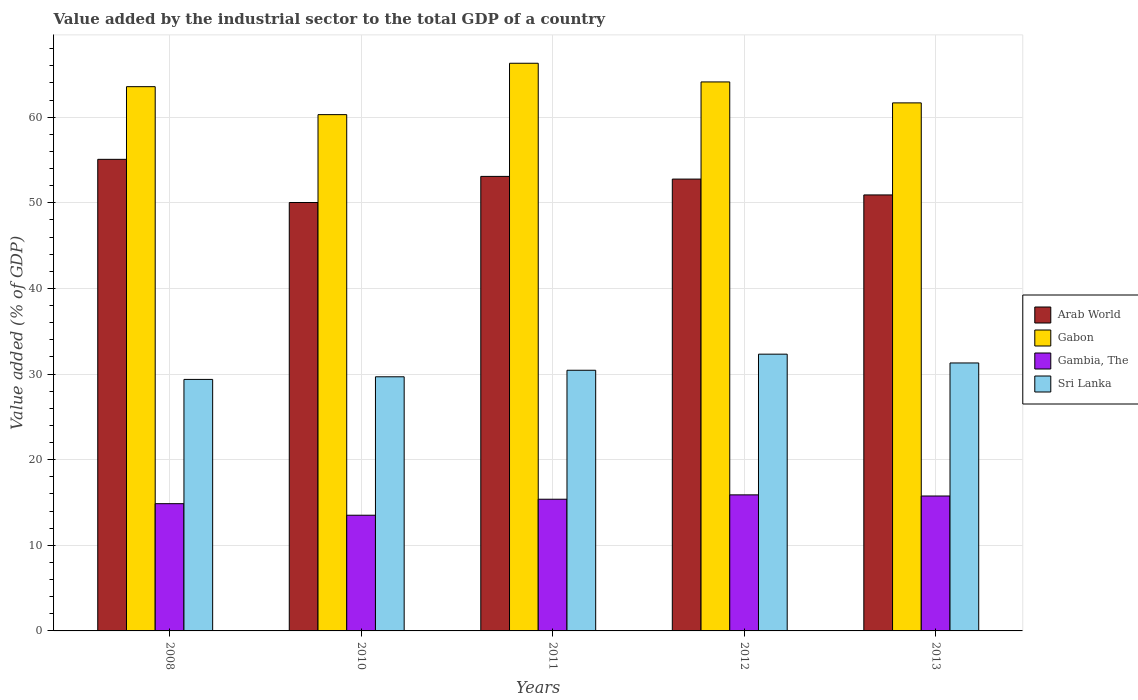How many bars are there on the 4th tick from the left?
Provide a short and direct response. 4. How many bars are there on the 4th tick from the right?
Ensure brevity in your answer.  4. What is the label of the 2nd group of bars from the left?
Your response must be concise. 2010. What is the value added by the industrial sector to the total GDP in Sri Lanka in 2011?
Provide a succinct answer. 30.44. Across all years, what is the maximum value added by the industrial sector to the total GDP in Sri Lanka?
Your answer should be compact. 32.32. Across all years, what is the minimum value added by the industrial sector to the total GDP in Gabon?
Offer a very short reply. 60.29. In which year was the value added by the industrial sector to the total GDP in Gabon minimum?
Provide a short and direct response. 2010. What is the total value added by the industrial sector to the total GDP in Arab World in the graph?
Ensure brevity in your answer.  261.87. What is the difference between the value added by the industrial sector to the total GDP in Gambia, The in 2011 and that in 2012?
Your answer should be very brief. -0.51. What is the difference between the value added by the industrial sector to the total GDP in Arab World in 2008 and the value added by the industrial sector to the total GDP in Gambia, The in 2010?
Your answer should be compact. 41.56. What is the average value added by the industrial sector to the total GDP in Gabon per year?
Provide a succinct answer. 63.18. In the year 2013, what is the difference between the value added by the industrial sector to the total GDP in Arab World and value added by the industrial sector to the total GDP in Gabon?
Your answer should be very brief. -10.75. What is the ratio of the value added by the industrial sector to the total GDP in Arab World in 2008 to that in 2010?
Your response must be concise. 1.1. Is the difference between the value added by the industrial sector to the total GDP in Arab World in 2011 and 2013 greater than the difference between the value added by the industrial sector to the total GDP in Gabon in 2011 and 2013?
Your answer should be very brief. No. What is the difference between the highest and the second highest value added by the industrial sector to the total GDP in Gabon?
Provide a short and direct response. 2.18. What is the difference between the highest and the lowest value added by the industrial sector to the total GDP in Sri Lanka?
Make the answer very short. 2.95. Is the sum of the value added by the industrial sector to the total GDP in Arab World in 2010 and 2013 greater than the maximum value added by the industrial sector to the total GDP in Gabon across all years?
Ensure brevity in your answer.  Yes. What does the 1st bar from the left in 2010 represents?
Your answer should be compact. Arab World. What does the 2nd bar from the right in 2008 represents?
Make the answer very short. Gambia, The. Are all the bars in the graph horizontal?
Your answer should be very brief. No. What is the difference between two consecutive major ticks on the Y-axis?
Provide a succinct answer. 10. Are the values on the major ticks of Y-axis written in scientific E-notation?
Provide a short and direct response. No. Does the graph contain grids?
Your answer should be very brief. Yes. How many legend labels are there?
Give a very brief answer. 4. How are the legend labels stacked?
Give a very brief answer. Vertical. What is the title of the graph?
Provide a succinct answer. Value added by the industrial sector to the total GDP of a country. What is the label or title of the X-axis?
Give a very brief answer. Years. What is the label or title of the Y-axis?
Give a very brief answer. Value added (% of GDP). What is the Value added (% of GDP) of Arab World in 2008?
Offer a very short reply. 55.07. What is the Value added (% of GDP) of Gabon in 2008?
Your answer should be very brief. 63.56. What is the Value added (% of GDP) in Gambia, The in 2008?
Your answer should be compact. 14.86. What is the Value added (% of GDP) in Sri Lanka in 2008?
Offer a terse response. 29.37. What is the Value added (% of GDP) in Arab World in 2010?
Offer a very short reply. 50.03. What is the Value added (% of GDP) in Gabon in 2010?
Provide a succinct answer. 60.29. What is the Value added (% of GDP) in Gambia, The in 2010?
Your answer should be very brief. 13.51. What is the Value added (% of GDP) of Sri Lanka in 2010?
Your answer should be very brief. 29.68. What is the Value added (% of GDP) in Arab World in 2011?
Your response must be concise. 53.08. What is the Value added (% of GDP) of Gabon in 2011?
Your response must be concise. 66.29. What is the Value added (% of GDP) in Gambia, The in 2011?
Give a very brief answer. 15.38. What is the Value added (% of GDP) of Sri Lanka in 2011?
Your answer should be very brief. 30.44. What is the Value added (% of GDP) in Arab World in 2012?
Your answer should be compact. 52.77. What is the Value added (% of GDP) in Gabon in 2012?
Ensure brevity in your answer.  64.11. What is the Value added (% of GDP) in Gambia, The in 2012?
Offer a terse response. 15.89. What is the Value added (% of GDP) in Sri Lanka in 2012?
Your answer should be very brief. 32.32. What is the Value added (% of GDP) in Arab World in 2013?
Ensure brevity in your answer.  50.92. What is the Value added (% of GDP) in Gabon in 2013?
Keep it short and to the point. 61.67. What is the Value added (% of GDP) in Gambia, The in 2013?
Provide a succinct answer. 15.75. What is the Value added (% of GDP) in Sri Lanka in 2013?
Your response must be concise. 31.29. Across all years, what is the maximum Value added (% of GDP) of Arab World?
Offer a terse response. 55.07. Across all years, what is the maximum Value added (% of GDP) in Gabon?
Ensure brevity in your answer.  66.29. Across all years, what is the maximum Value added (% of GDP) in Gambia, The?
Your response must be concise. 15.89. Across all years, what is the maximum Value added (% of GDP) of Sri Lanka?
Offer a very short reply. 32.32. Across all years, what is the minimum Value added (% of GDP) of Arab World?
Provide a succinct answer. 50.03. Across all years, what is the minimum Value added (% of GDP) of Gabon?
Give a very brief answer. 60.29. Across all years, what is the minimum Value added (% of GDP) in Gambia, The?
Ensure brevity in your answer.  13.51. Across all years, what is the minimum Value added (% of GDP) of Sri Lanka?
Make the answer very short. 29.37. What is the total Value added (% of GDP) in Arab World in the graph?
Make the answer very short. 261.87. What is the total Value added (% of GDP) of Gabon in the graph?
Your response must be concise. 315.92. What is the total Value added (% of GDP) of Gambia, The in the graph?
Your response must be concise. 75.39. What is the total Value added (% of GDP) in Sri Lanka in the graph?
Make the answer very short. 153.1. What is the difference between the Value added (% of GDP) of Arab World in 2008 and that in 2010?
Your answer should be very brief. 5.04. What is the difference between the Value added (% of GDP) of Gabon in 2008 and that in 2010?
Your response must be concise. 3.27. What is the difference between the Value added (% of GDP) in Gambia, The in 2008 and that in 2010?
Keep it short and to the point. 1.35. What is the difference between the Value added (% of GDP) of Sri Lanka in 2008 and that in 2010?
Your response must be concise. -0.31. What is the difference between the Value added (% of GDP) of Arab World in 2008 and that in 2011?
Your response must be concise. 1.99. What is the difference between the Value added (% of GDP) of Gabon in 2008 and that in 2011?
Your answer should be very brief. -2.73. What is the difference between the Value added (% of GDP) of Gambia, The in 2008 and that in 2011?
Your answer should be compact. -0.52. What is the difference between the Value added (% of GDP) of Sri Lanka in 2008 and that in 2011?
Your response must be concise. -1.07. What is the difference between the Value added (% of GDP) of Arab World in 2008 and that in 2012?
Provide a short and direct response. 2.31. What is the difference between the Value added (% of GDP) in Gabon in 2008 and that in 2012?
Provide a succinct answer. -0.55. What is the difference between the Value added (% of GDP) of Gambia, The in 2008 and that in 2012?
Your answer should be compact. -1.03. What is the difference between the Value added (% of GDP) in Sri Lanka in 2008 and that in 2012?
Make the answer very short. -2.95. What is the difference between the Value added (% of GDP) of Arab World in 2008 and that in 2013?
Offer a very short reply. 4.16. What is the difference between the Value added (% of GDP) of Gabon in 2008 and that in 2013?
Your answer should be compact. 1.89. What is the difference between the Value added (% of GDP) of Gambia, The in 2008 and that in 2013?
Make the answer very short. -0.89. What is the difference between the Value added (% of GDP) of Sri Lanka in 2008 and that in 2013?
Provide a short and direct response. -1.92. What is the difference between the Value added (% of GDP) in Arab World in 2010 and that in 2011?
Make the answer very short. -3.05. What is the difference between the Value added (% of GDP) of Gabon in 2010 and that in 2011?
Provide a succinct answer. -6. What is the difference between the Value added (% of GDP) of Gambia, The in 2010 and that in 2011?
Provide a succinct answer. -1.87. What is the difference between the Value added (% of GDP) of Sri Lanka in 2010 and that in 2011?
Your answer should be compact. -0.76. What is the difference between the Value added (% of GDP) of Arab World in 2010 and that in 2012?
Provide a succinct answer. -2.73. What is the difference between the Value added (% of GDP) in Gabon in 2010 and that in 2012?
Your response must be concise. -3.82. What is the difference between the Value added (% of GDP) of Gambia, The in 2010 and that in 2012?
Give a very brief answer. -2.38. What is the difference between the Value added (% of GDP) of Sri Lanka in 2010 and that in 2012?
Your answer should be compact. -2.64. What is the difference between the Value added (% of GDP) of Arab World in 2010 and that in 2013?
Give a very brief answer. -0.89. What is the difference between the Value added (% of GDP) in Gabon in 2010 and that in 2013?
Your answer should be very brief. -1.37. What is the difference between the Value added (% of GDP) of Gambia, The in 2010 and that in 2013?
Your response must be concise. -2.24. What is the difference between the Value added (% of GDP) of Sri Lanka in 2010 and that in 2013?
Your answer should be compact. -1.61. What is the difference between the Value added (% of GDP) of Arab World in 2011 and that in 2012?
Give a very brief answer. 0.31. What is the difference between the Value added (% of GDP) of Gabon in 2011 and that in 2012?
Offer a very short reply. 2.18. What is the difference between the Value added (% of GDP) in Gambia, The in 2011 and that in 2012?
Your answer should be compact. -0.51. What is the difference between the Value added (% of GDP) of Sri Lanka in 2011 and that in 2012?
Your answer should be compact. -1.88. What is the difference between the Value added (% of GDP) of Arab World in 2011 and that in 2013?
Provide a succinct answer. 2.16. What is the difference between the Value added (% of GDP) of Gabon in 2011 and that in 2013?
Make the answer very short. 4.63. What is the difference between the Value added (% of GDP) of Gambia, The in 2011 and that in 2013?
Your response must be concise. -0.37. What is the difference between the Value added (% of GDP) in Sri Lanka in 2011 and that in 2013?
Make the answer very short. -0.85. What is the difference between the Value added (% of GDP) in Arab World in 2012 and that in 2013?
Your response must be concise. 1.85. What is the difference between the Value added (% of GDP) of Gabon in 2012 and that in 2013?
Offer a terse response. 2.45. What is the difference between the Value added (% of GDP) in Gambia, The in 2012 and that in 2013?
Offer a terse response. 0.13. What is the difference between the Value added (% of GDP) of Sri Lanka in 2012 and that in 2013?
Provide a succinct answer. 1.03. What is the difference between the Value added (% of GDP) of Arab World in 2008 and the Value added (% of GDP) of Gabon in 2010?
Ensure brevity in your answer.  -5.22. What is the difference between the Value added (% of GDP) in Arab World in 2008 and the Value added (% of GDP) in Gambia, The in 2010?
Offer a very short reply. 41.56. What is the difference between the Value added (% of GDP) of Arab World in 2008 and the Value added (% of GDP) of Sri Lanka in 2010?
Make the answer very short. 25.4. What is the difference between the Value added (% of GDP) of Gabon in 2008 and the Value added (% of GDP) of Gambia, The in 2010?
Provide a short and direct response. 50.05. What is the difference between the Value added (% of GDP) of Gabon in 2008 and the Value added (% of GDP) of Sri Lanka in 2010?
Provide a succinct answer. 33.88. What is the difference between the Value added (% of GDP) of Gambia, The in 2008 and the Value added (% of GDP) of Sri Lanka in 2010?
Provide a succinct answer. -14.82. What is the difference between the Value added (% of GDP) of Arab World in 2008 and the Value added (% of GDP) of Gabon in 2011?
Provide a succinct answer. -11.22. What is the difference between the Value added (% of GDP) in Arab World in 2008 and the Value added (% of GDP) in Gambia, The in 2011?
Offer a terse response. 39.69. What is the difference between the Value added (% of GDP) of Arab World in 2008 and the Value added (% of GDP) of Sri Lanka in 2011?
Provide a succinct answer. 24.63. What is the difference between the Value added (% of GDP) in Gabon in 2008 and the Value added (% of GDP) in Gambia, The in 2011?
Offer a very short reply. 48.18. What is the difference between the Value added (% of GDP) of Gabon in 2008 and the Value added (% of GDP) of Sri Lanka in 2011?
Provide a succinct answer. 33.12. What is the difference between the Value added (% of GDP) of Gambia, The in 2008 and the Value added (% of GDP) of Sri Lanka in 2011?
Provide a short and direct response. -15.58. What is the difference between the Value added (% of GDP) in Arab World in 2008 and the Value added (% of GDP) in Gabon in 2012?
Your response must be concise. -9.04. What is the difference between the Value added (% of GDP) of Arab World in 2008 and the Value added (% of GDP) of Gambia, The in 2012?
Provide a succinct answer. 39.18. What is the difference between the Value added (% of GDP) in Arab World in 2008 and the Value added (% of GDP) in Sri Lanka in 2012?
Keep it short and to the point. 22.75. What is the difference between the Value added (% of GDP) in Gabon in 2008 and the Value added (% of GDP) in Gambia, The in 2012?
Make the answer very short. 47.67. What is the difference between the Value added (% of GDP) of Gabon in 2008 and the Value added (% of GDP) of Sri Lanka in 2012?
Offer a very short reply. 31.24. What is the difference between the Value added (% of GDP) in Gambia, The in 2008 and the Value added (% of GDP) in Sri Lanka in 2012?
Provide a short and direct response. -17.46. What is the difference between the Value added (% of GDP) in Arab World in 2008 and the Value added (% of GDP) in Gabon in 2013?
Your response must be concise. -6.59. What is the difference between the Value added (% of GDP) in Arab World in 2008 and the Value added (% of GDP) in Gambia, The in 2013?
Offer a very short reply. 39.32. What is the difference between the Value added (% of GDP) of Arab World in 2008 and the Value added (% of GDP) of Sri Lanka in 2013?
Give a very brief answer. 23.78. What is the difference between the Value added (% of GDP) of Gabon in 2008 and the Value added (% of GDP) of Gambia, The in 2013?
Ensure brevity in your answer.  47.8. What is the difference between the Value added (% of GDP) of Gabon in 2008 and the Value added (% of GDP) of Sri Lanka in 2013?
Your response must be concise. 32.27. What is the difference between the Value added (% of GDP) of Gambia, The in 2008 and the Value added (% of GDP) of Sri Lanka in 2013?
Give a very brief answer. -16.43. What is the difference between the Value added (% of GDP) in Arab World in 2010 and the Value added (% of GDP) in Gabon in 2011?
Keep it short and to the point. -16.26. What is the difference between the Value added (% of GDP) of Arab World in 2010 and the Value added (% of GDP) of Gambia, The in 2011?
Give a very brief answer. 34.65. What is the difference between the Value added (% of GDP) in Arab World in 2010 and the Value added (% of GDP) in Sri Lanka in 2011?
Your response must be concise. 19.59. What is the difference between the Value added (% of GDP) in Gabon in 2010 and the Value added (% of GDP) in Gambia, The in 2011?
Your answer should be very brief. 44.91. What is the difference between the Value added (% of GDP) of Gabon in 2010 and the Value added (% of GDP) of Sri Lanka in 2011?
Ensure brevity in your answer.  29.85. What is the difference between the Value added (% of GDP) of Gambia, The in 2010 and the Value added (% of GDP) of Sri Lanka in 2011?
Keep it short and to the point. -16.93. What is the difference between the Value added (% of GDP) of Arab World in 2010 and the Value added (% of GDP) of Gabon in 2012?
Make the answer very short. -14.08. What is the difference between the Value added (% of GDP) of Arab World in 2010 and the Value added (% of GDP) of Gambia, The in 2012?
Keep it short and to the point. 34.14. What is the difference between the Value added (% of GDP) in Arab World in 2010 and the Value added (% of GDP) in Sri Lanka in 2012?
Provide a short and direct response. 17.71. What is the difference between the Value added (% of GDP) of Gabon in 2010 and the Value added (% of GDP) of Gambia, The in 2012?
Your response must be concise. 44.4. What is the difference between the Value added (% of GDP) in Gabon in 2010 and the Value added (% of GDP) in Sri Lanka in 2012?
Keep it short and to the point. 27.97. What is the difference between the Value added (% of GDP) in Gambia, The in 2010 and the Value added (% of GDP) in Sri Lanka in 2012?
Make the answer very short. -18.81. What is the difference between the Value added (% of GDP) in Arab World in 2010 and the Value added (% of GDP) in Gabon in 2013?
Your response must be concise. -11.63. What is the difference between the Value added (% of GDP) in Arab World in 2010 and the Value added (% of GDP) in Gambia, The in 2013?
Make the answer very short. 34.28. What is the difference between the Value added (% of GDP) of Arab World in 2010 and the Value added (% of GDP) of Sri Lanka in 2013?
Your response must be concise. 18.74. What is the difference between the Value added (% of GDP) of Gabon in 2010 and the Value added (% of GDP) of Gambia, The in 2013?
Make the answer very short. 44.54. What is the difference between the Value added (% of GDP) in Gabon in 2010 and the Value added (% of GDP) in Sri Lanka in 2013?
Your answer should be compact. 29. What is the difference between the Value added (% of GDP) in Gambia, The in 2010 and the Value added (% of GDP) in Sri Lanka in 2013?
Your answer should be compact. -17.78. What is the difference between the Value added (% of GDP) in Arab World in 2011 and the Value added (% of GDP) in Gabon in 2012?
Your answer should be very brief. -11.03. What is the difference between the Value added (% of GDP) of Arab World in 2011 and the Value added (% of GDP) of Gambia, The in 2012?
Your answer should be compact. 37.19. What is the difference between the Value added (% of GDP) in Arab World in 2011 and the Value added (% of GDP) in Sri Lanka in 2012?
Provide a succinct answer. 20.76. What is the difference between the Value added (% of GDP) of Gabon in 2011 and the Value added (% of GDP) of Gambia, The in 2012?
Your response must be concise. 50.4. What is the difference between the Value added (% of GDP) in Gabon in 2011 and the Value added (% of GDP) in Sri Lanka in 2012?
Your answer should be very brief. 33.97. What is the difference between the Value added (% of GDP) in Gambia, The in 2011 and the Value added (% of GDP) in Sri Lanka in 2012?
Offer a very short reply. -16.94. What is the difference between the Value added (% of GDP) in Arab World in 2011 and the Value added (% of GDP) in Gabon in 2013?
Offer a terse response. -8.59. What is the difference between the Value added (% of GDP) of Arab World in 2011 and the Value added (% of GDP) of Gambia, The in 2013?
Your answer should be compact. 37.33. What is the difference between the Value added (% of GDP) in Arab World in 2011 and the Value added (% of GDP) in Sri Lanka in 2013?
Offer a very short reply. 21.79. What is the difference between the Value added (% of GDP) of Gabon in 2011 and the Value added (% of GDP) of Gambia, The in 2013?
Make the answer very short. 50.54. What is the difference between the Value added (% of GDP) in Gabon in 2011 and the Value added (% of GDP) in Sri Lanka in 2013?
Your answer should be compact. 35. What is the difference between the Value added (% of GDP) in Gambia, The in 2011 and the Value added (% of GDP) in Sri Lanka in 2013?
Offer a terse response. -15.91. What is the difference between the Value added (% of GDP) in Arab World in 2012 and the Value added (% of GDP) in Gabon in 2013?
Keep it short and to the point. -8.9. What is the difference between the Value added (% of GDP) of Arab World in 2012 and the Value added (% of GDP) of Gambia, The in 2013?
Ensure brevity in your answer.  37.01. What is the difference between the Value added (% of GDP) in Arab World in 2012 and the Value added (% of GDP) in Sri Lanka in 2013?
Provide a short and direct response. 21.47. What is the difference between the Value added (% of GDP) of Gabon in 2012 and the Value added (% of GDP) of Gambia, The in 2013?
Offer a very short reply. 48.36. What is the difference between the Value added (% of GDP) of Gabon in 2012 and the Value added (% of GDP) of Sri Lanka in 2013?
Your answer should be very brief. 32.82. What is the difference between the Value added (% of GDP) in Gambia, The in 2012 and the Value added (% of GDP) in Sri Lanka in 2013?
Your answer should be very brief. -15.4. What is the average Value added (% of GDP) of Arab World per year?
Keep it short and to the point. 52.37. What is the average Value added (% of GDP) of Gabon per year?
Provide a short and direct response. 63.18. What is the average Value added (% of GDP) of Gambia, The per year?
Offer a terse response. 15.08. What is the average Value added (% of GDP) in Sri Lanka per year?
Offer a terse response. 30.62. In the year 2008, what is the difference between the Value added (% of GDP) of Arab World and Value added (% of GDP) of Gabon?
Ensure brevity in your answer.  -8.49. In the year 2008, what is the difference between the Value added (% of GDP) of Arab World and Value added (% of GDP) of Gambia, The?
Your answer should be compact. 40.21. In the year 2008, what is the difference between the Value added (% of GDP) in Arab World and Value added (% of GDP) in Sri Lanka?
Make the answer very short. 25.7. In the year 2008, what is the difference between the Value added (% of GDP) in Gabon and Value added (% of GDP) in Gambia, The?
Offer a terse response. 48.7. In the year 2008, what is the difference between the Value added (% of GDP) in Gabon and Value added (% of GDP) in Sri Lanka?
Your answer should be compact. 34.19. In the year 2008, what is the difference between the Value added (% of GDP) of Gambia, The and Value added (% of GDP) of Sri Lanka?
Keep it short and to the point. -14.51. In the year 2010, what is the difference between the Value added (% of GDP) in Arab World and Value added (% of GDP) in Gabon?
Provide a short and direct response. -10.26. In the year 2010, what is the difference between the Value added (% of GDP) in Arab World and Value added (% of GDP) in Gambia, The?
Provide a succinct answer. 36.52. In the year 2010, what is the difference between the Value added (% of GDP) in Arab World and Value added (% of GDP) in Sri Lanka?
Your answer should be very brief. 20.35. In the year 2010, what is the difference between the Value added (% of GDP) in Gabon and Value added (% of GDP) in Gambia, The?
Offer a very short reply. 46.78. In the year 2010, what is the difference between the Value added (% of GDP) in Gabon and Value added (% of GDP) in Sri Lanka?
Give a very brief answer. 30.62. In the year 2010, what is the difference between the Value added (% of GDP) of Gambia, The and Value added (% of GDP) of Sri Lanka?
Make the answer very short. -16.17. In the year 2011, what is the difference between the Value added (% of GDP) in Arab World and Value added (% of GDP) in Gabon?
Give a very brief answer. -13.21. In the year 2011, what is the difference between the Value added (% of GDP) in Arab World and Value added (% of GDP) in Gambia, The?
Your answer should be compact. 37.7. In the year 2011, what is the difference between the Value added (% of GDP) in Arab World and Value added (% of GDP) in Sri Lanka?
Ensure brevity in your answer.  22.64. In the year 2011, what is the difference between the Value added (% of GDP) of Gabon and Value added (% of GDP) of Gambia, The?
Give a very brief answer. 50.91. In the year 2011, what is the difference between the Value added (% of GDP) in Gabon and Value added (% of GDP) in Sri Lanka?
Give a very brief answer. 35.85. In the year 2011, what is the difference between the Value added (% of GDP) in Gambia, The and Value added (% of GDP) in Sri Lanka?
Give a very brief answer. -15.06. In the year 2012, what is the difference between the Value added (% of GDP) of Arab World and Value added (% of GDP) of Gabon?
Make the answer very short. -11.35. In the year 2012, what is the difference between the Value added (% of GDP) in Arab World and Value added (% of GDP) in Gambia, The?
Offer a very short reply. 36.88. In the year 2012, what is the difference between the Value added (% of GDP) in Arab World and Value added (% of GDP) in Sri Lanka?
Make the answer very short. 20.44. In the year 2012, what is the difference between the Value added (% of GDP) of Gabon and Value added (% of GDP) of Gambia, The?
Give a very brief answer. 48.22. In the year 2012, what is the difference between the Value added (% of GDP) of Gabon and Value added (% of GDP) of Sri Lanka?
Ensure brevity in your answer.  31.79. In the year 2012, what is the difference between the Value added (% of GDP) in Gambia, The and Value added (% of GDP) in Sri Lanka?
Provide a succinct answer. -16.43. In the year 2013, what is the difference between the Value added (% of GDP) of Arab World and Value added (% of GDP) of Gabon?
Ensure brevity in your answer.  -10.75. In the year 2013, what is the difference between the Value added (% of GDP) of Arab World and Value added (% of GDP) of Gambia, The?
Offer a terse response. 35.16. In the year 2013, what is the difference between the Value added (% of GDP) in Arab World and Value added (% of GDP) in Sri Lanka?
Keep it short and to the point. 19.62. In the year 2013, what is the difference between the Value added (% of GDP) in Gabon and Value added (% of GDP) in Gambia, The?
Your response must be concise. 45.91. In the year 2013, what is the difference between the Value added (% of GDP) of Gabon and Value added (% of GDP) of Sri Lanka?
Provide a succinct answer. 30.37. In the year 2013, what is the difference between the Value added (% of GDP) in Gambia, The and Value added (% of GDP) in Sri Lanka?
Give a very brief answer. -15.54. What is the ratio of the Value added (% of GDP) of Arab World in 2008 to that in 2010?
Your response must be concise. 1.1. What is the ratio of the Value added (% of GDP) of Gabon in 2008 to that in 2010?
Offer a terse response. 1.05. What is the ratio of the Value added (% of GDP) in Gambia, The in 2008 to that in 2010?
Offer a terse response. 1.1. What is the ratio of the Value added (% of GDP) of Arab World in 2008 to that in 2011?
Make the answer very short. 1.04. What is the ratio of the Value added (% of GDP) in Gabon in 2008 to that in 2011?
Make the answer very short. 0.96. What is the ratio of the Value added (% of GDP) of Gambia, The in 2008 to that in 2011?
Provide a succinct answer. 0.97. What is the ratio of the Value added (% of GDP) in Sri Lanka in 2008 to that in 2011?
Offer a very short reply. 0.96. What is the ratio of the Value added (% of GDP) of Arab World in 2008 to that in 2012?
Offer a terse response. 1.04. What is the ratio of the Value added (% of GDP) in Gambia, The in 2008 to that in 2012?
Offer a terse response. 0.94. What is the ratio of the Value added (% of GDP) in Sri Lanka in 2008 to that in 2012?
Provide a succinct answer. 0.91. What is the ratio of the Value added (% of GDP) in Arab World in 2008 to that in 2013?
Give a very brief answer. 1.08. What is the ratio of the Value added (% of GDP) of Gabon in 2008 to that in 2013?
Your response must be concise. 1.03. What is the ratio of the Value added (% of GDP) in Gambia, The in 2008 to that in 2013?
Make the answer very short. 0.94. What is the ratio of the Value added (% of GDP) in Sri Lanka in 2008 to that in 2013?
Keep it short and to the point. 0.94. What is the ratio of the Value added (% of GDP) in Arab World in 2010 to that in 2011?
Provide a short and direct response. 0.94. What is the ratio of the Value added (% of GDP) of Gabon in 2010 to that in 2011?
Make the answer very short. 0.91. What is the ratio of the Value added (% of GDP) in Gambia, The in 2010 to that in 2011?
Give a very brief answer. 0.88. What is the ratio of the Value added (% of GDP) of Sri Lanka in 2010 to that in 2011?
Provide a short and direct response. 0.97. What is the ratio of the Value added (% of GDP) of Arab World in 2010 to that in 2012?
Your answer should be very brief. 0.95. What is the ratio of the Value added (% of GDP) of Gabon in 2010 to that in 2012?
Your answer should be compact. 0.94. What is the ratio of the Value added (% of GDP) of Gambia, The in 2010 to that in 2012?
Provide a succinct answer. 0.85. What is the ratio of the Value added (% of GDP) of Sri Lanka in 2010 to that in 2012?
Offer a very short reply. 0.92. What is the ratio of the Value added (% of GDP) in Arab World in 2010 to that in 2013?
Give a very brief answer. 0.98. What is the ratio of the Value added (% of GDP) of Gabon in 2010 to that in 2013?
Your response must be concise. 0.98. What is the ratio of the Value added (% of GDP) in Gambia, The in 2010 to that in 2013?
Offer a very short reply. 0.86. What is the ratio of the Value added (% of GDP) in Sri Lanka in 2010 to that in 2013?
Offer a terse response. 0.95. What is the ratio of the Value added (% of GDP) in Gabon in 2011 to that in 2012?
Your answer should be very brief. 1.03. What is the ratio of the Value added (% of GDP) in Gambia, The in 2011 to that in 2012?
Provide a short and direct response. 0.97. What is the ratio of the Value added (% of GDP) of Sri Lanka in 2011 to that in 2012?
Your answer should be very brief. 0.94. What is the ratio of the Value added (% of GDP) of Arab World in 2011 to that in 2013?
Keep it short and to the point. 1.04. What is the ratio of the Value added (% of GDP) in Gabon in 2011 to that in 2013?
Ensure brevity in your answer.  1.07. What is the ratio of the Value added (% of GDP) of Gambia, The in 2011 to that in 2013?
Provide a short and direct response. 0.98. What is the ratio of the Value added (% of GDP) of Sri Lanka in 2011 to that in 2013?
Make the answer very short. 0.97. What is the ratio of the Value added (% of GDP) in Arab World in 2012 to that in 2013?
Your answer should be very brief. 1.04. What is the ratio of the Value added (% of GDP) in Gabon in 2012 to that in 2013?
Ensure brevity in your answer.  1.04. What is the ratio of the Value added (% of GDP) of Gambia, The in 2012 to that in 2013?
Your response must be concise. 1.01. What is the ratio of the Value added (% of GDP) of Sri Lanka in 2012 to that in 2013?
Keep it short and to the point. 1.03. What is the difference between the highest and the second highest Value added (% of GDP) in Arab World?
Offer a terse response. 1.99. What is the difference between the highest and the second highest Value added (% of GDP) in Gabon?
Your answer should be compact. 2.18. What is the difference between the highest and the second highest Value added (% of GDP) in Gambia, The?
Your answer should be very brief. 0.13. What is the difference between the highest and the second highest Value added (% of GDP) of Sri Lanka?
Provide a succinct answer. 1.03. What is the difference between the highest and the lowest Value added (% of GDP) of Arab World?
Provide a succinct answer. 5.04. What is the difference between the highest and the lowest Value added (% of GDP) in Gabon?
Provide a succinct answer. 6. What is the difference between the highest and the lowest Value added (% of GDP) of Gambia, The?
Your response must be concise. 2.38. What is the difference between the highest and the lowest Value added (% of GDP) in Sri Lanka?
Offer a very short reply. 2.95. 